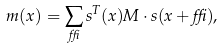Convert formula to latex. <formula><loc_0><loc_0><loc_500><loc_500>m ( { x } ) = \sum _ { \delta } { s } ^ { T } ( x ) { M } \cdot { s } ( { x } + \delta ) ,</formula> 